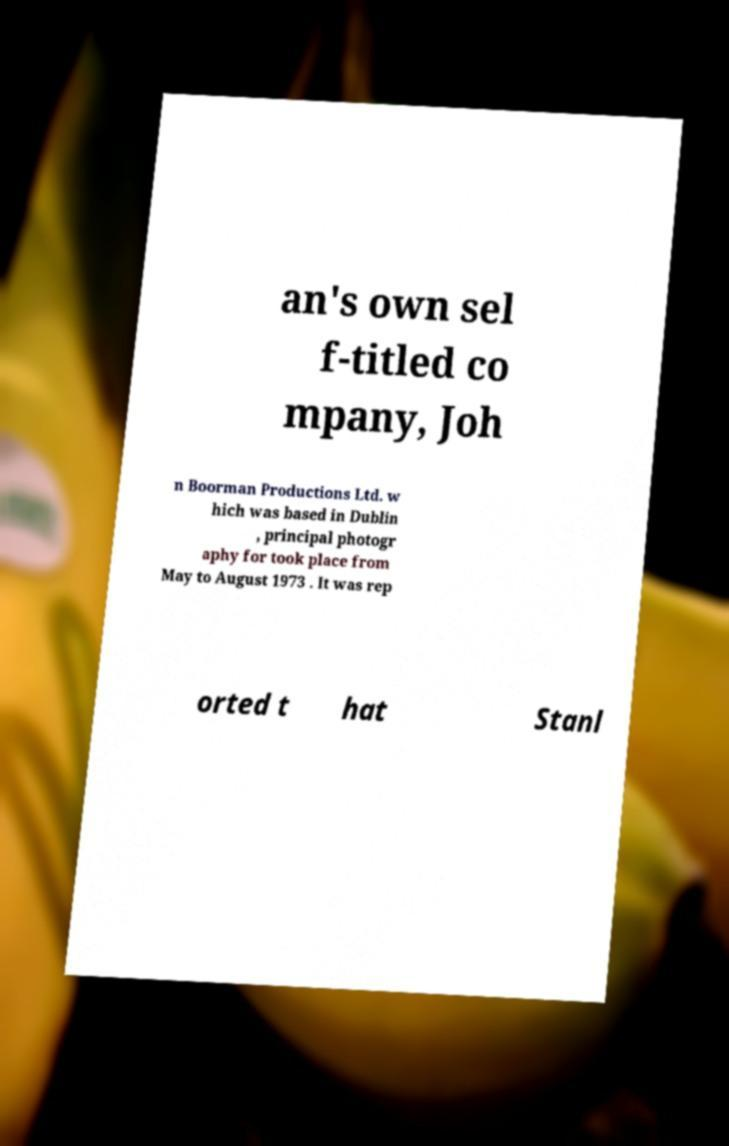Can you read and provide the text displayed in the image?This photo seems to have some interesting text. Can you extract and type it out for me? an's own sel f-titled co mpany, Joh n Boorman Productions Ltd. w hich was based in Dublin , principal photogr aphy for took place from May to August 1973 . It was rep orted t hat Stanl 